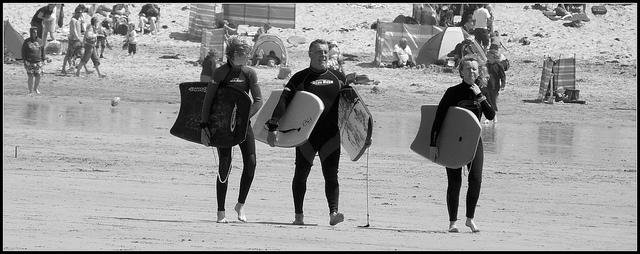What is the gender of the person in the middle?
Give a very brief answer. Male. What color is he photo?
Keep it brief. Black and white. How many people are carrying surfboards?
Give a very brief answer. 3. 